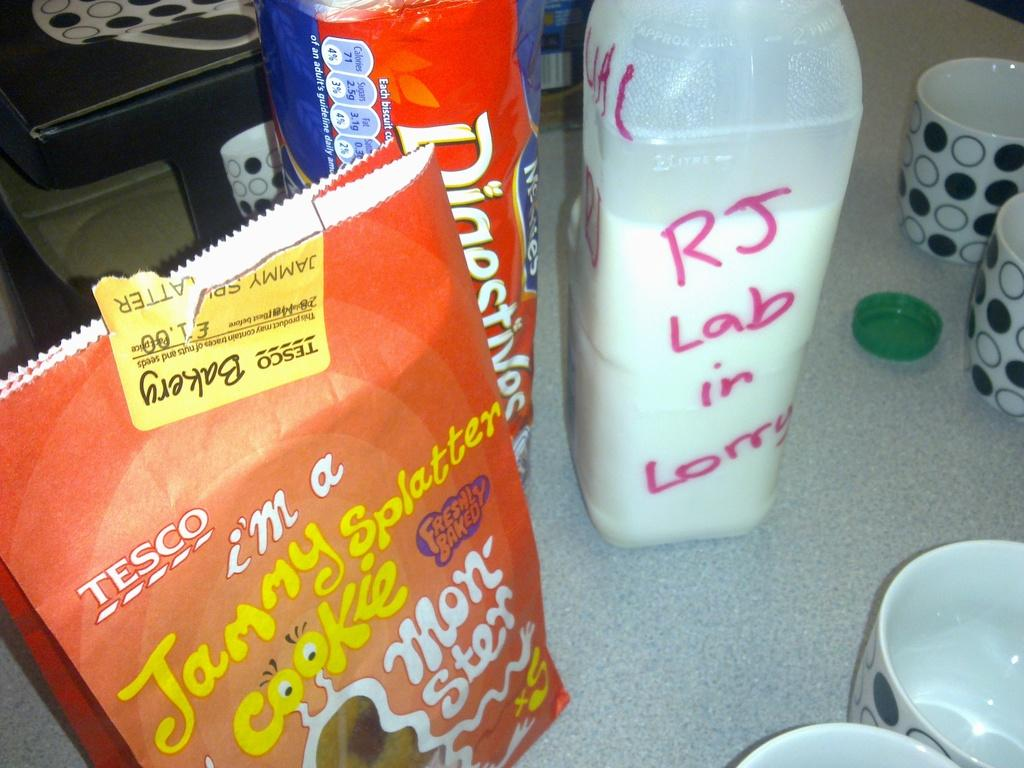<image>
Give a short and clear explanation of the subsequent image. Several food items, including Jammy Splatter cookies, sit on a counter. 